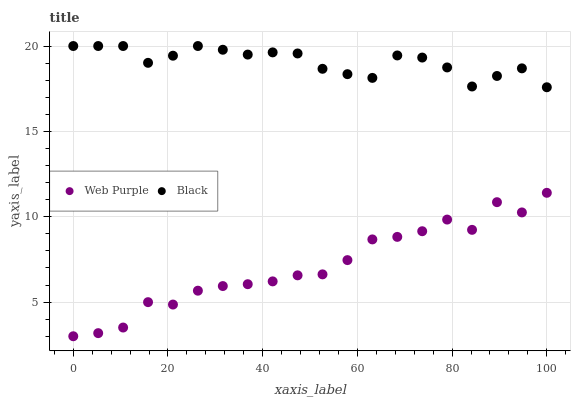Does Web Purple have the minimum area under the curve?
Answer yes or no. Yes. Does Black have the maximum area under the curve?
Answer yes or no. Yes. Does Black have the minimum area under the curve?
Answer yes or no. No. Is Black the smoothest?
Answer yes or no. Yes. Is Web Purple the roughest?
Answer yes or no. Yes. Is Black the roughest?
Answer yes or no. No. Does Web Purple have the lowest value?
Answer yes or no. Yes. Does Black have the lowest value?
Answer yes or no. No. Does Black have the highest value?
Answer yes or no. Yes. Is Web Purple less than Black?
Answer yes or no. Yes. Is Black greater than Web Purple?
Answer yes or no. Yes. Does Web Purple intersect Black?
Answer yes or no. No. 